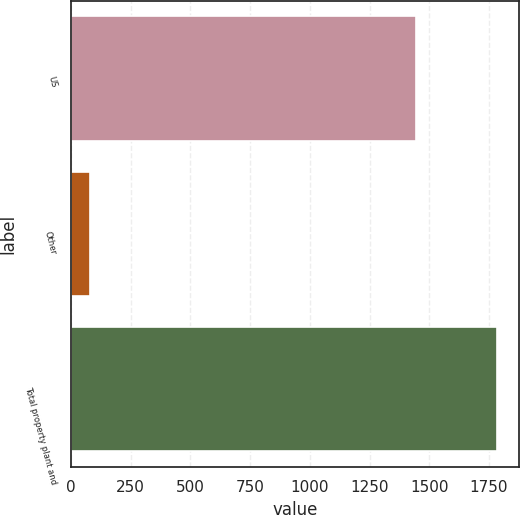Convert chart. <chart><loc_0><loc_0><loc_500><loc_500><bar_chart><fcel>US<fcel>Other<fcel>Total property plant and<nl><fcel>1443.7<fcel>80.8<fcel>1784.7<nl></chart> 